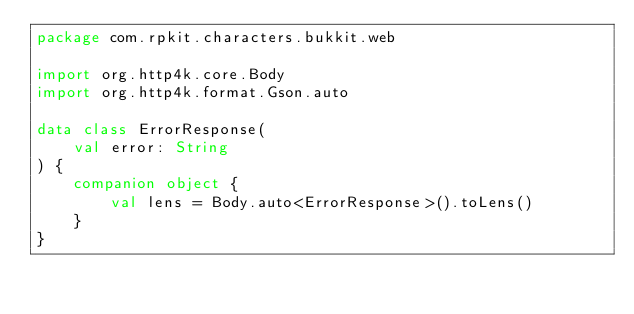Convert code to text. <code><loc_0><loc_0><loc_500><loc_500><_Kotlin_>package com.rpkit.characters.bukkit.web

import org.http4k.core.Body
import org.http4k.format.Gson.auto

data class ErrorResponse(
    val error: String
) {
    companion object {
        val lens = Body.auto<ErrorResponse>().toLens()
    }
}</code> 